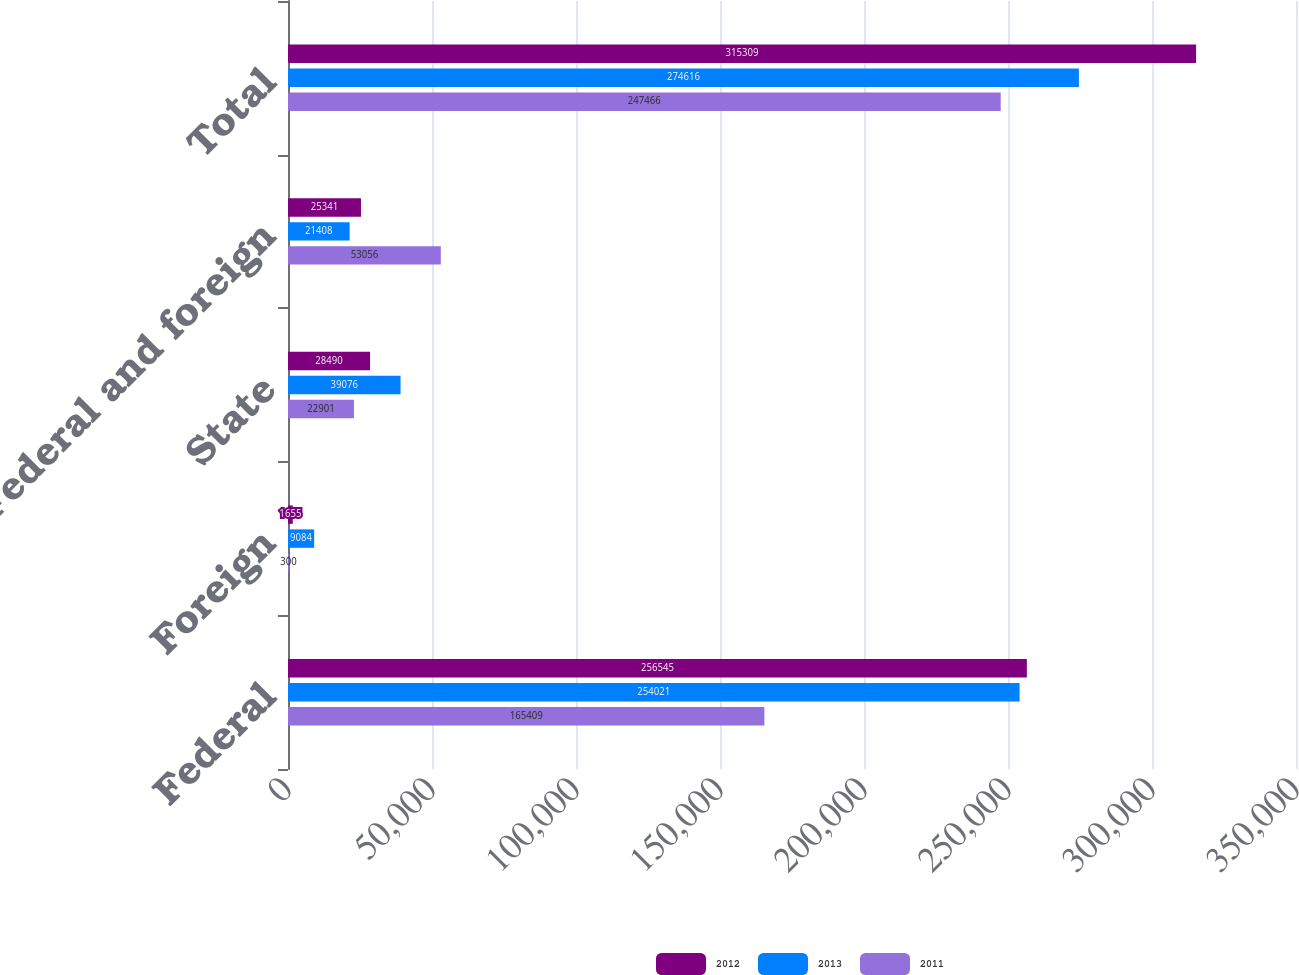Convert chart. <chart><loc_0><loc_0><loc_500><loc_500><stacked_bar_chart><ecel><fcel>Federal<fcel>Foreign<fcel>State<fcel>Federal and foreign<fcel>Total<nl><fcel>2012<fcel>256545<fcel>1655<fcel>28490<fcel>25341<fcel>315309<nl><fcel>2013<fcel>254021<fcel>9084<fcel>39076<fcel>21408<fcel>274616<nl><fcel>2011<fcel>165409<fcel>300<fcel>22901<fcel>53056<fcel>247466<nl></chart> 